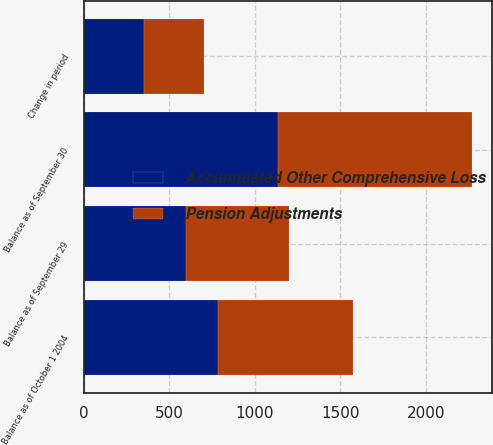Convert chart to OTSL. <chart><loc_0><loc_0><loc_500><loc_500><stacked_bar_chart><ecel><fcel>Balance as of October 1 2004<fcel>Change in period<fcel>Balance as of September 30<fcel>Balance as of September 29<nl><fcel>Pension Adjustments<fcel>786<fcel>351<fcel>1137<fcel>599<nl><fcel>Accumulated Other Comprehensive Loss<fcel>786<fcel>351<fcel>1137<fcel>599<nl></chart> 